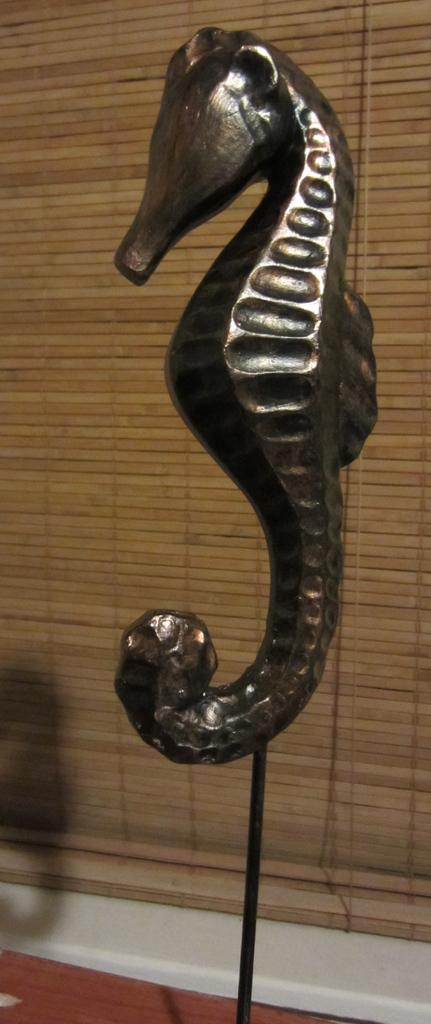What is the main subject of the image? There is a seahorse depicted in the image. What can be seen in the background of the image? There is a window mat in the background of the image. How many roses are present in the image? There are no roses depicted in the image; it features a seahorse and a window mat. Can you tell me if the seahorse is running in the image? The seahorse is not running in the image, as it is a stationary depiction. 